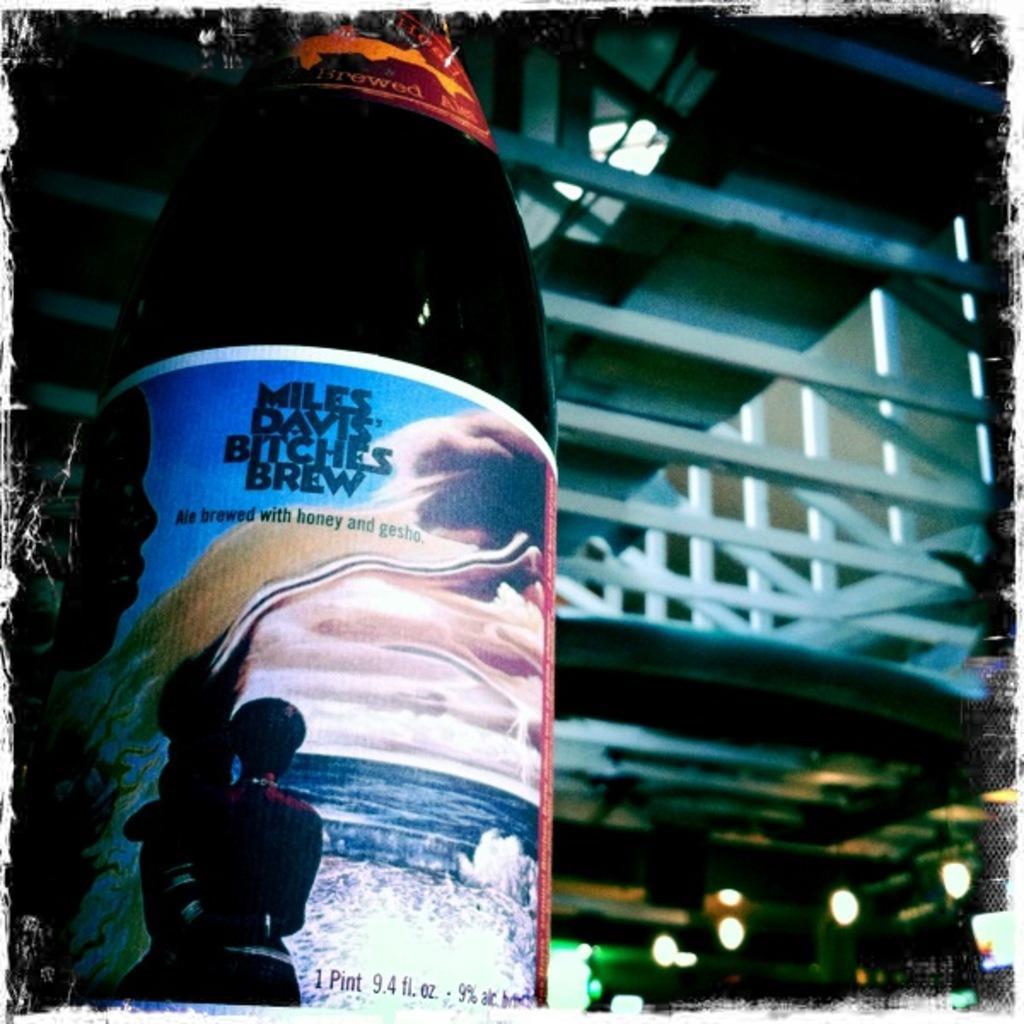In one or two sentences, can you explain what this image depicts? This picture shows a bottle. And in the background there is a building and some lights here. 